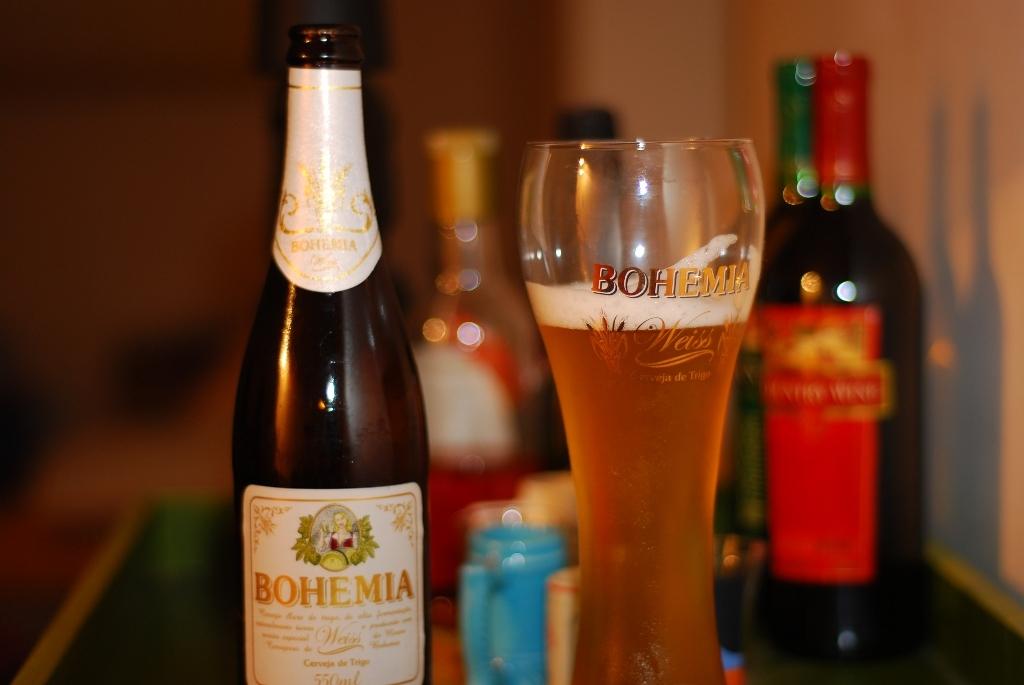What is the company on the front of the bottle and glass?
Offer a terse response. Bohemia. 